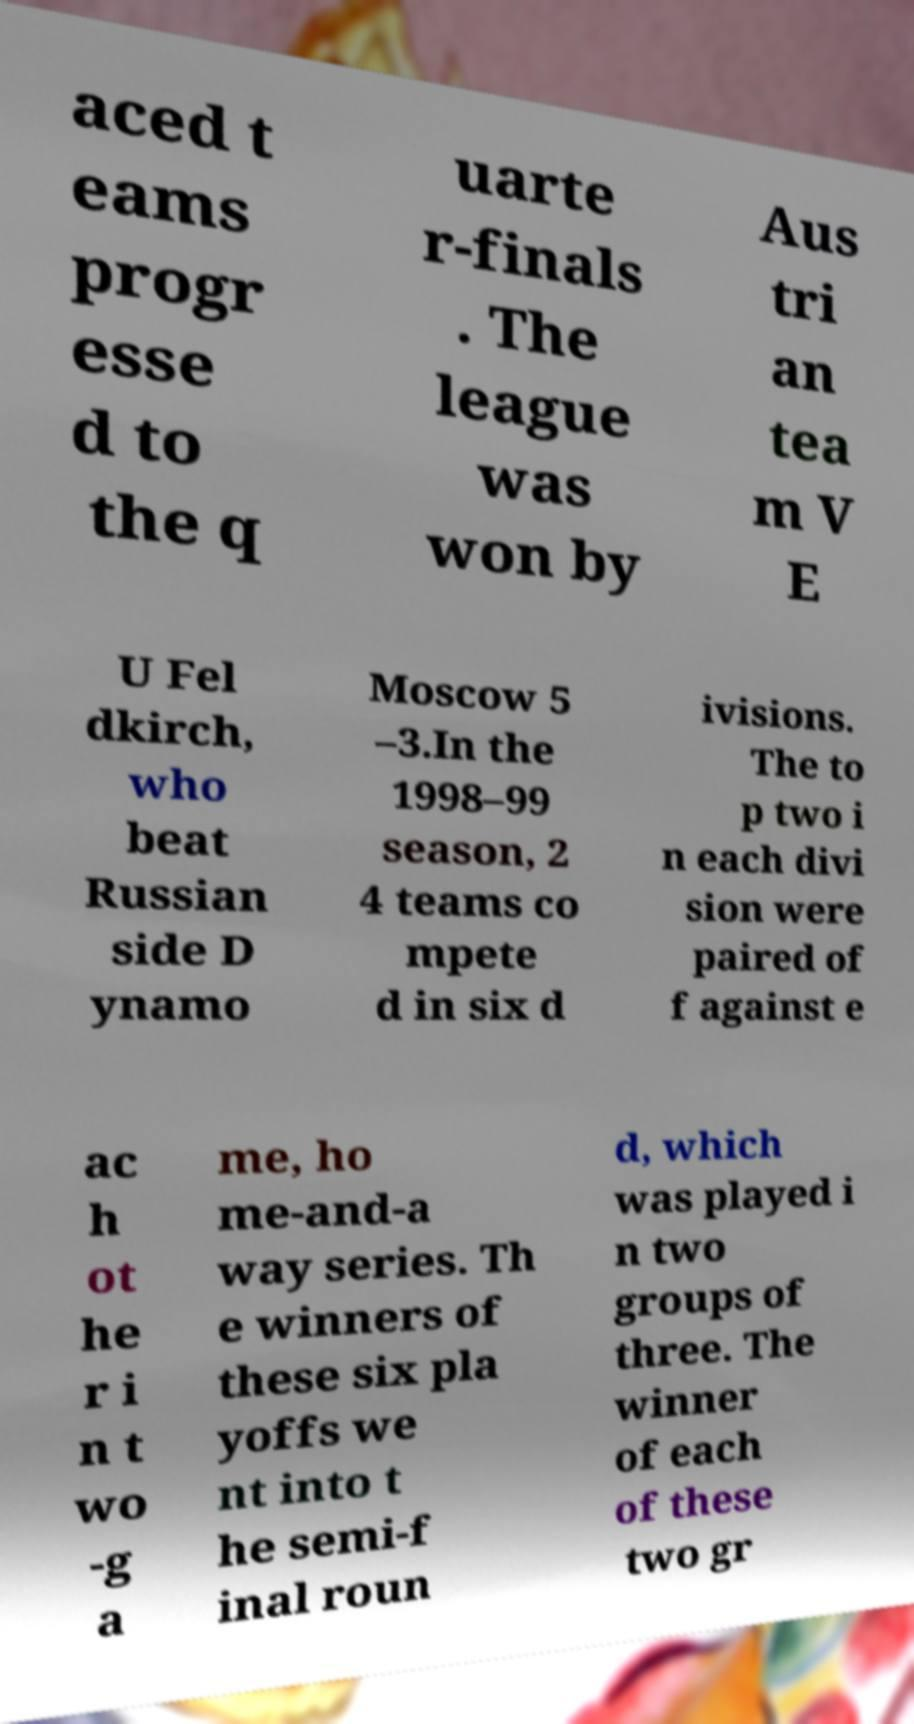For documentation purposes, I need the text within this image transcribed. Could you provide that? aced t eams progr esse d to the q uarte r-finals . The league was won by Aus tri an tea m V E U Fel dkirch, who beat Russian side D ynamo Moscow 5 –3.In the 1998–99 season, 2 4 teams co mpete d in six d ivisions. The to p two i n each divi sion were paired of f against e ac h ot he r i n t wo -g a me, ho me-and-a way series. Th e winners of these six pla yoffs we nt into t he semi-f inal roun d, which was played i n two groups of three. The winner of each of these two gr 